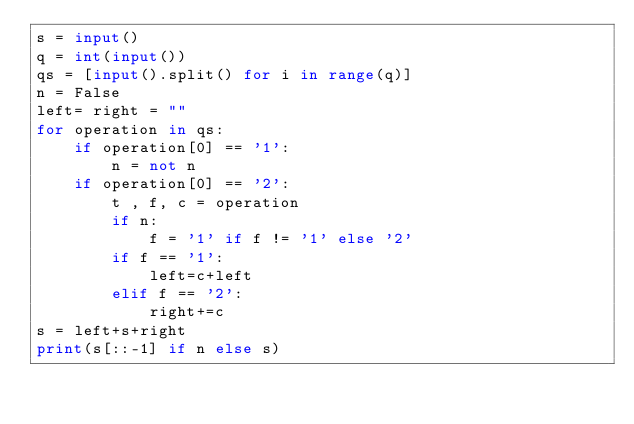Convert code to text. <code><loc_0><loc_0><loc_500><loc_500><_Python_>s = input()
q = int(input())
qs = [input().split() for i in range(q)]
n = False
left= right = ""
for operation in qs:
    if operation[0] == '1':
        n = not n
    if operation[0] == '2':
        t , f, c = operation
        if n:
            f = '1' if f != '1' else '2'
        if f == '1':
            left=c+left
        elif f == '2':
            right+=c
s = left+s+right
print(s[::-1] if n else s)</code> 